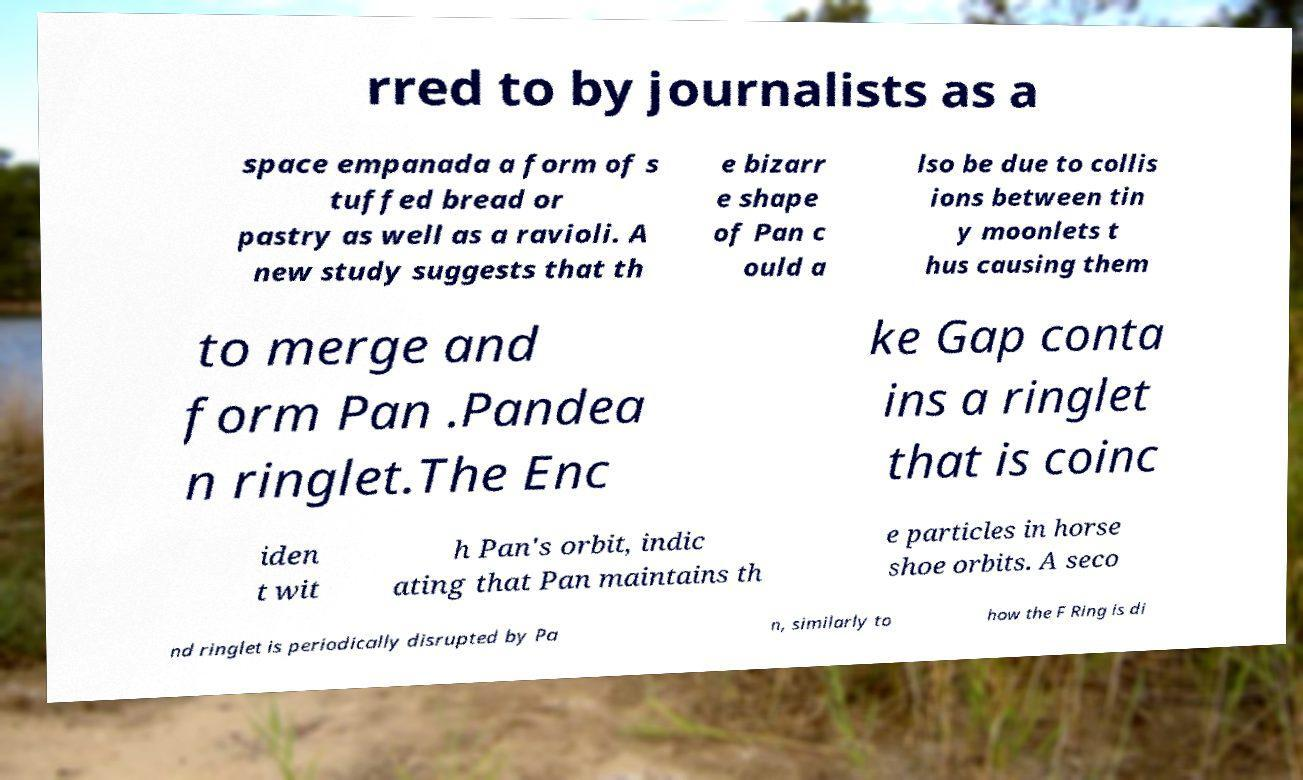Can you accurately transcribe the text from the provided image for me? rred to by journalists as a space empanada a form of s tuffed bread or pastry as well as a ravioli. A new study suggests that th e bizarr e shape of Pan c ould a lso be due to collis ions between tin y moonlets t hus causing them to merge and form Pan .Pandea n ringlet.The Enc ke Gap conta ins a ringlet that is coinc iden t wit h Pan's orbit, indic ating that Pan maintains th e particles in horse shoe orbits. A seco nd ringlet is periodically disrupted by Pa n, similarly to how the F Ring is di 